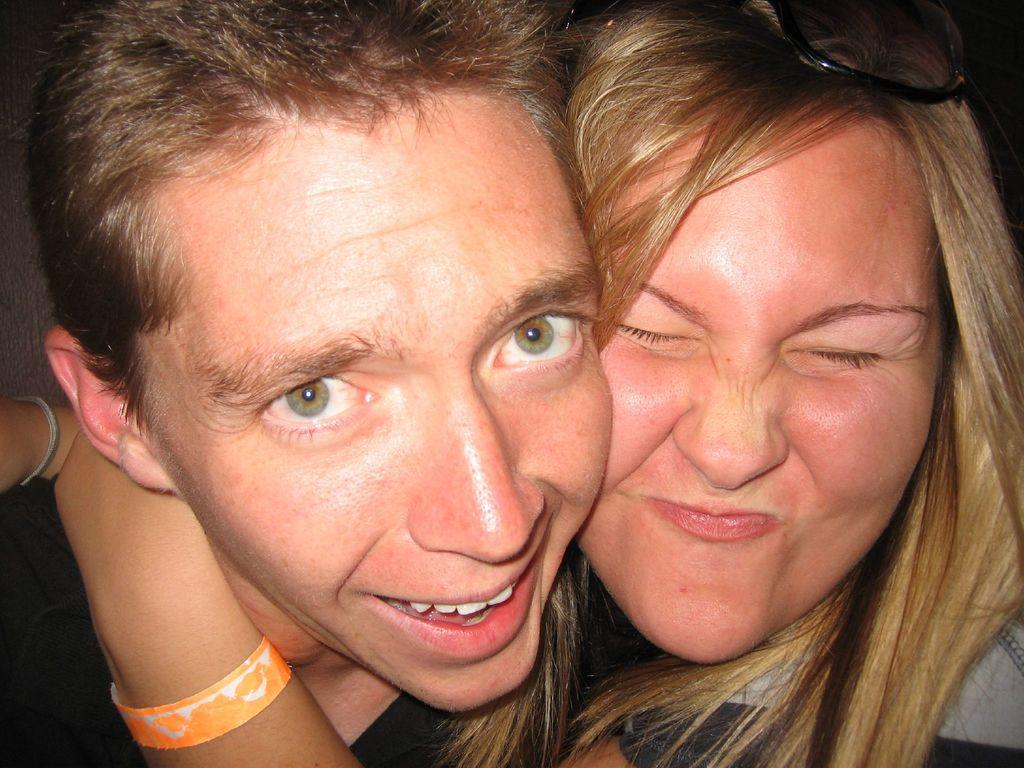How many people are in the image? There are two persons in the image. What expressions do the people have in the image? Both persons are smiling in the image. What type of tree is growing out of the person's head in the image? There is no tree growing out of anyone's head in the image. Can you tell me how many keys are visible in the image? There are no keys present in the image. 